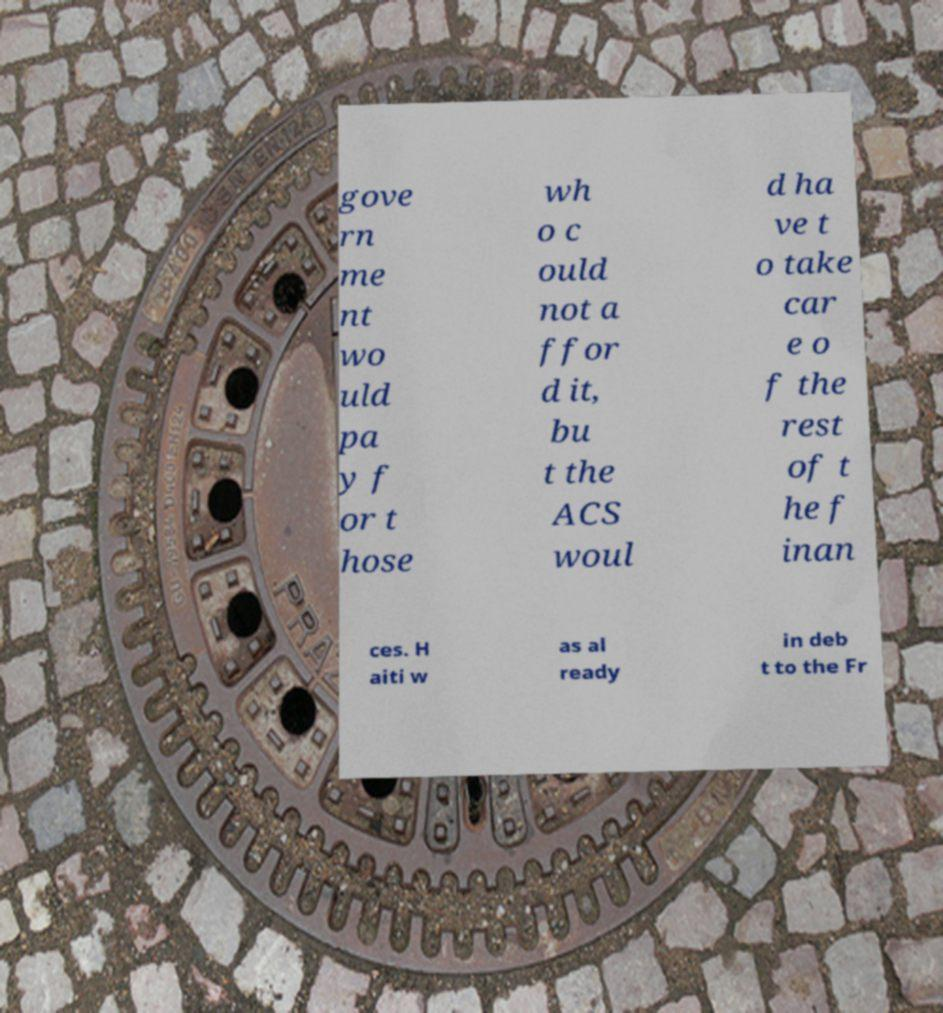Could you assist in decoding the text presented in this image and type it out clearly? gove rn me nt wo uld pa y f or t hose wh o c ould not a ffor d it, bu t the ACS woul d ha ve t o take car e o f the rest of t he f inan ces. H aiti w as al ready in deb t to the Fr 